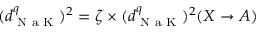Convert formula to latex. <formula><loc_0><loc_0><loc_500><loc_500>( d _ { N a K } ^ { q } ) ^ { 2 } = \zeta \times ( d _ { N a K } ^ { q } ) ^ { 2 } ( X \to A )</formula> 